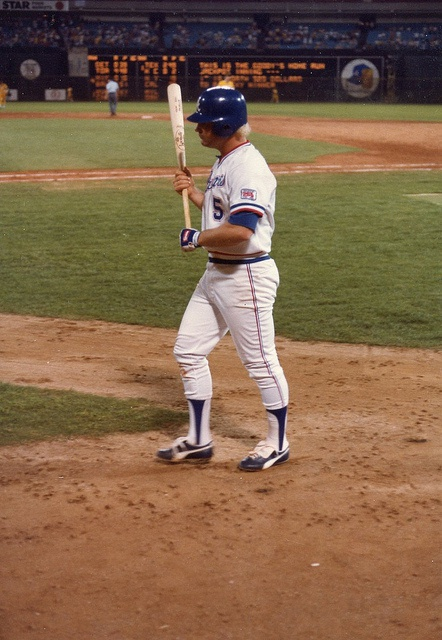Describe the objects in this image and their specific colors. I can see people in black, lightgray, darkgray, and gray tones, baseball bat in black, tan, and lightgray tones, people in black, gray, and darkgray tones, people in black, brown, maroon, and gray tones, and people in black, orange, brown, and maroon tones in this image. 